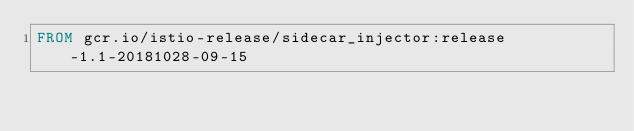Convert code to text. <code><loc_0><loc_0><loc_500><loc_500><_Dockerfile_>FROM gcr.io/istio-release/sidecar_injector:release-1.1-20181028-09-15
</code> 